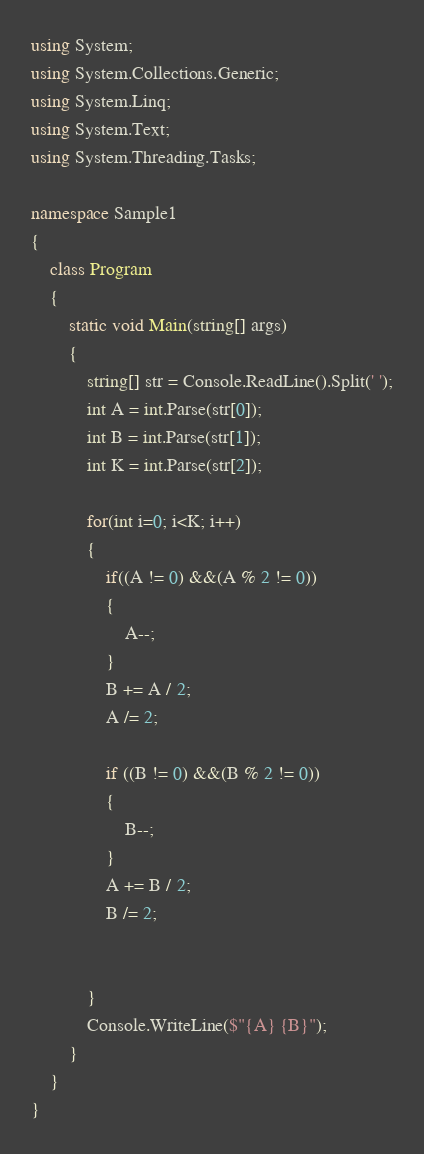Convert code to text. <code><loc_0><loc_0><loc_500><loc_500><_C#_>using System;
using System.Collections.Generic;
using System.Linq;
using System.Text;
using System.Threading.Tasks;

namespace Sample1
{
    class Program
    {
        static void Main(string[] args)
        {
            string[] str = Console.ReadLine().Split(' ');
            int A = int.Parse(str[0]);
            int B = int.Parse(str[1]);
            int K = int.Parse(str[2]);

            for(int i=0; i<K; i++)
            {
                if((A != 0) &&(A % 2 != 0))
                {
                    A--;
                }
                B += A / 2;
                A /= 2;

                if ((B != 0) &&(B % 2 != 0))
                {
                    B--;
                }
                A += B / 2;
                B /= 2;


            }
            Console.WriteLine($"{A} {B}");
        }
    }
}
</code> 